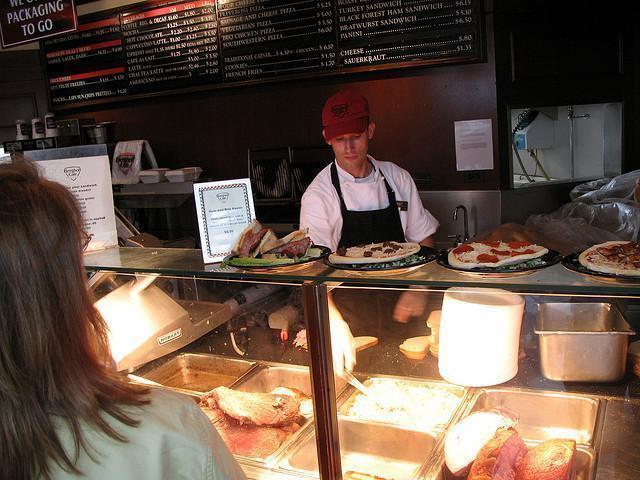What type of meat is most visible near the front of the glass?
Choose the right answer and clarify with the format: 'Answer: answer
Rationale: rationale.'
Options: Red meat, chicken, fake, fish. Answer: red meat.
Rationale: The meat is red meat. 